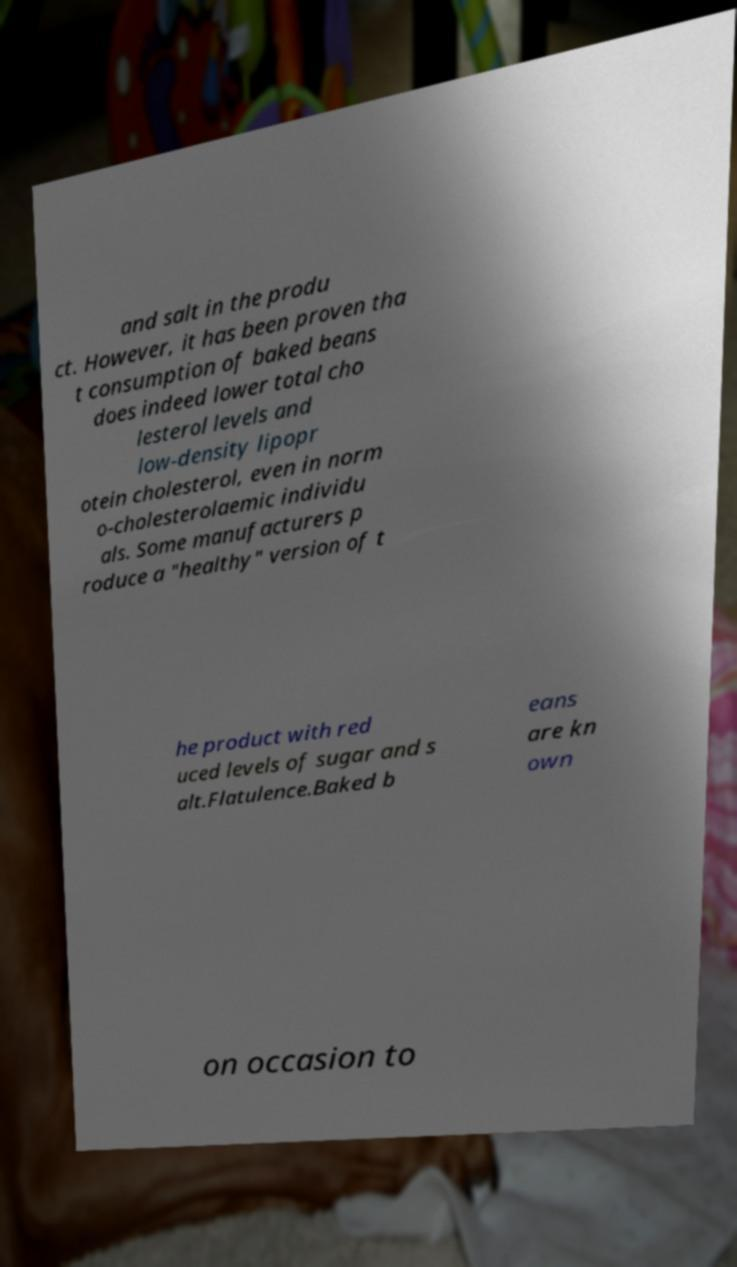What messages or text are displayed in this image? I need them in a readable, typed format. and salt in the produ ct. However, it has been proven tha t consumption of baked beans does indeed lower total cho lesterol levels and low-density lipopr otein cholesterol, even in norm o-cholesterolaemic individu als. Some manufacturers p roduce a "healthy" version of t he product with red uced levels of sugar and s alt.Flatulence.Baked b eans are kn own on occasion to 